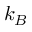Convert formula to latex. <formula><loc_0><loc_0><loc_500><loc_500>k _ { B }</formula> 